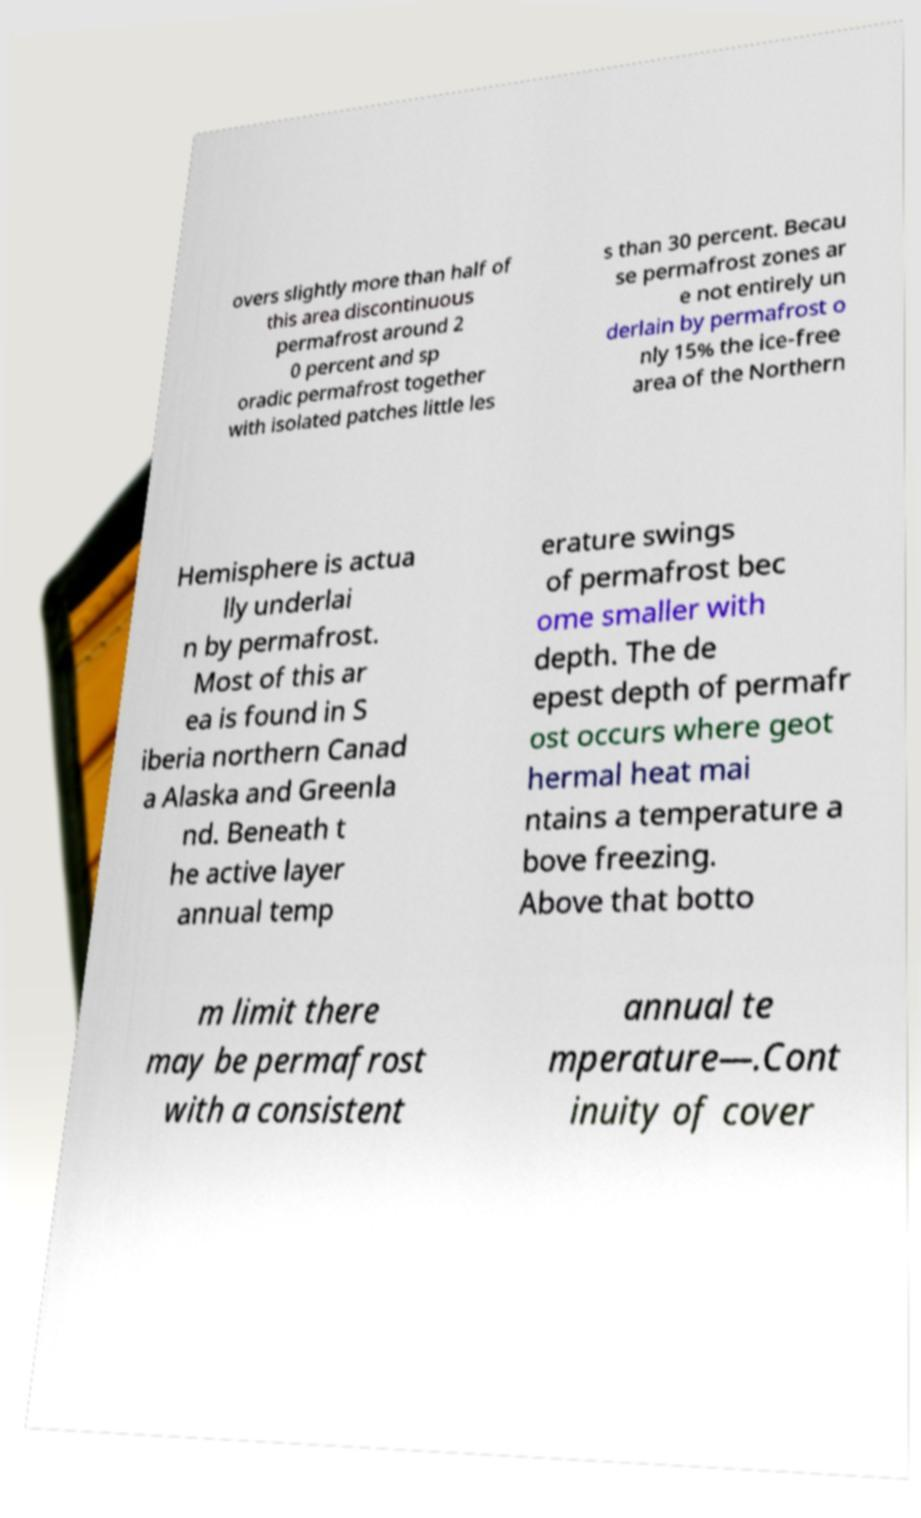Can you read and provide the text displayed in the image?This photo seems to have some interesting text. Can you extract and type it out for me? overs slightly more than half of this area discontinuous permafrost around 2 0 percent and sp oradic permafrost together with isolated patches little les s than 30 percent. Becau se permafrost zones ar e not entirely un derlain by permafrost o nly 15% the ice-free area of the Northern Hemisphere is actua lly underlai n by permafrost. Most of this ar ea is found in S iberia northern Canad a Alaska and Greenla nd. Beneath t he active layer annual temp erature swings of permafrost bec ome smaller with depth. The de epest depth of permafr ost occurs where geot hermal heat mai ntains a temperature a bove freezing. Above that botto m limit there may be permafrost with a consistent annual te mperature—.Cont inuity of cover 